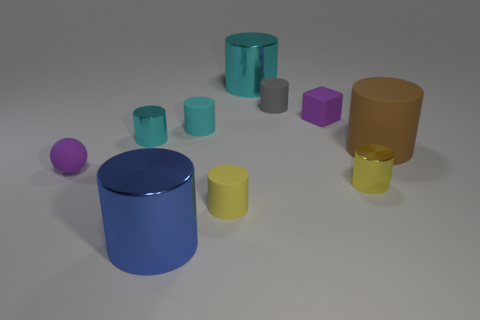Is the number of tiny gray matte things that are to the left of the blue metallic thing less than the number of brown matte cylinders?
Offer a terse response. Yes. What number of other objects are there of the same shape as the tiny yellow matte thing?
Your answer should be very brief. 7. What number of things are either purple objects that are on the left side of the small purple cube or tiny shiny objects on the left side of the small yellow metal cylinder?
Give a very brief answer. 2. How big is the metal object that is both in front of the gray thing and behind the rubber ball?
Provide a succinct answer. Small. Does the shiny object in front of the tiny yellow metallic cylinder have the same shape as the gray object?
Provide a succinct answer. Yes. There is a cyan metallic thing in front of the cyan shiny thing right of the large shiny thing in front of the tiny cyan shiny object; what is its size?
Provide a succinct answer. Small. What size is the rubber sphere that is the same color as the small cube?
Provide a succinct answer. Small. What number of objects are small purple matte cubes or small cyan things?
Offer a very short reply. 3. There is a thing that is both on the right side of the blue metallic cylinder and in front of the small yellow metal thing; what is its shape?
Your answer should be compact. Cylinder. Does the brown object have the same shape as the large shiny thing to the left of the tiny yellow matte cylinder?
Offer a terse response. Yes. 